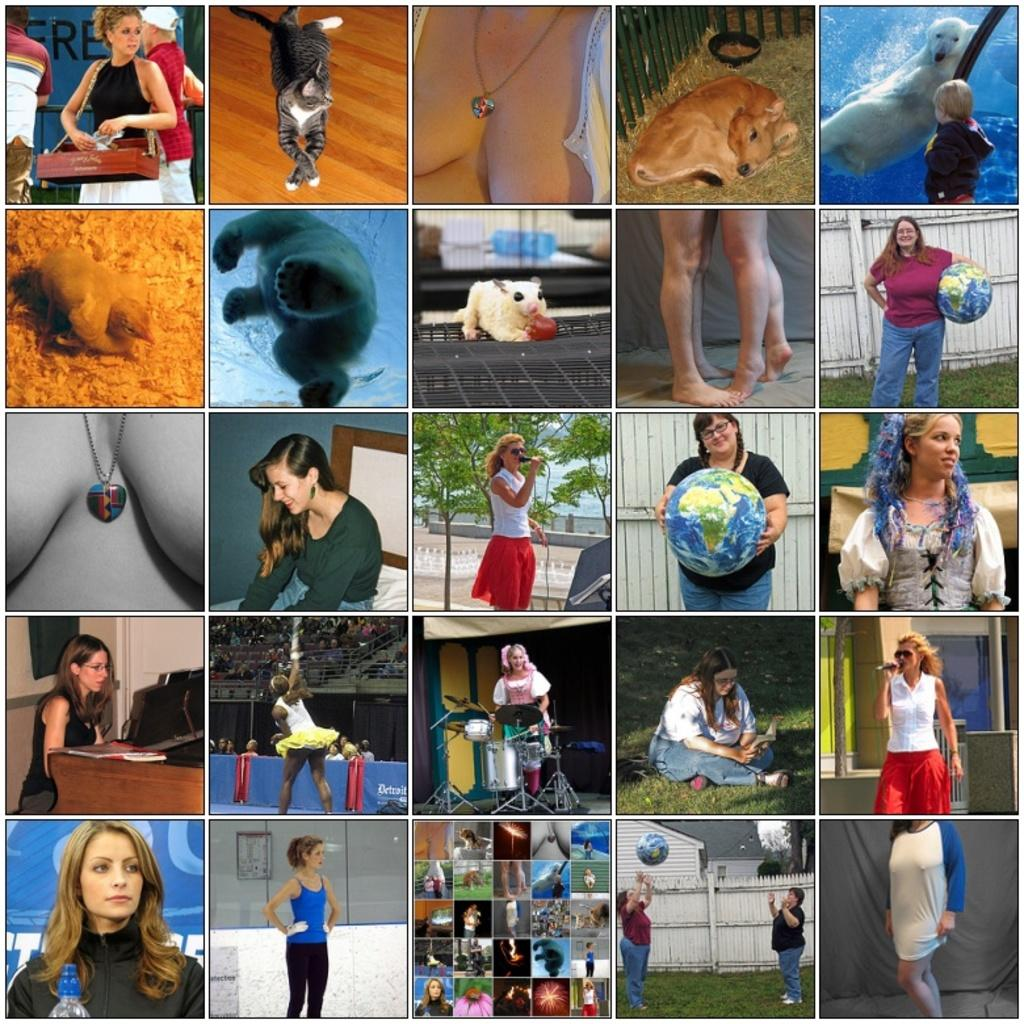What is the main subject of the image? The main subject of the image is a collage of photos. What types of photos are included in the collage? The collage contains photos of persons, animals, and lockets. What type of question is being asked in the image? There is no question present in the image; it is a collage of photos featuring persons, animals, and lockets. 